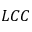Convert formula to latex. <formula><loc_0><loc_0><loc_500><loc_500>L C C</formula> 